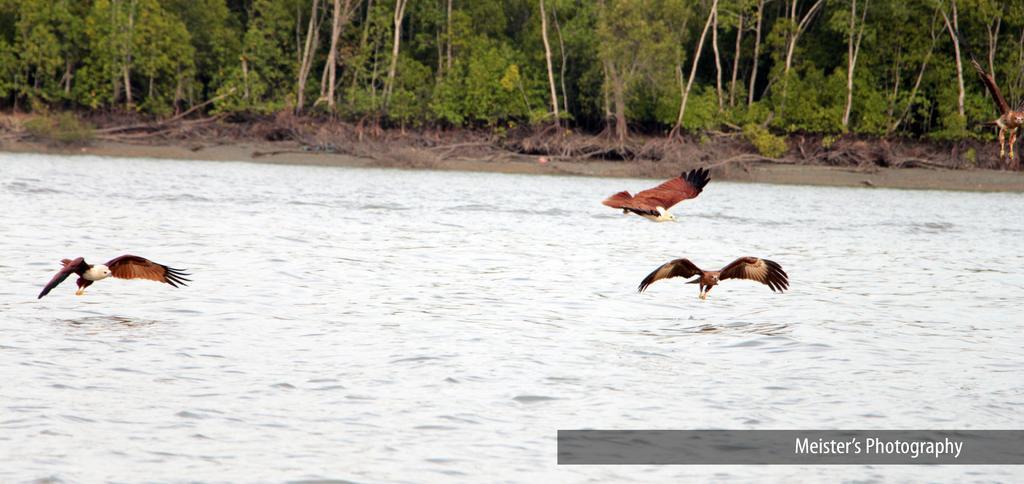Describe this image in one or two sentences. In this image there are birds in the air. At the bottom of the image there is water. In the background of the image there are trees and there is some text written on the right side of the image. 